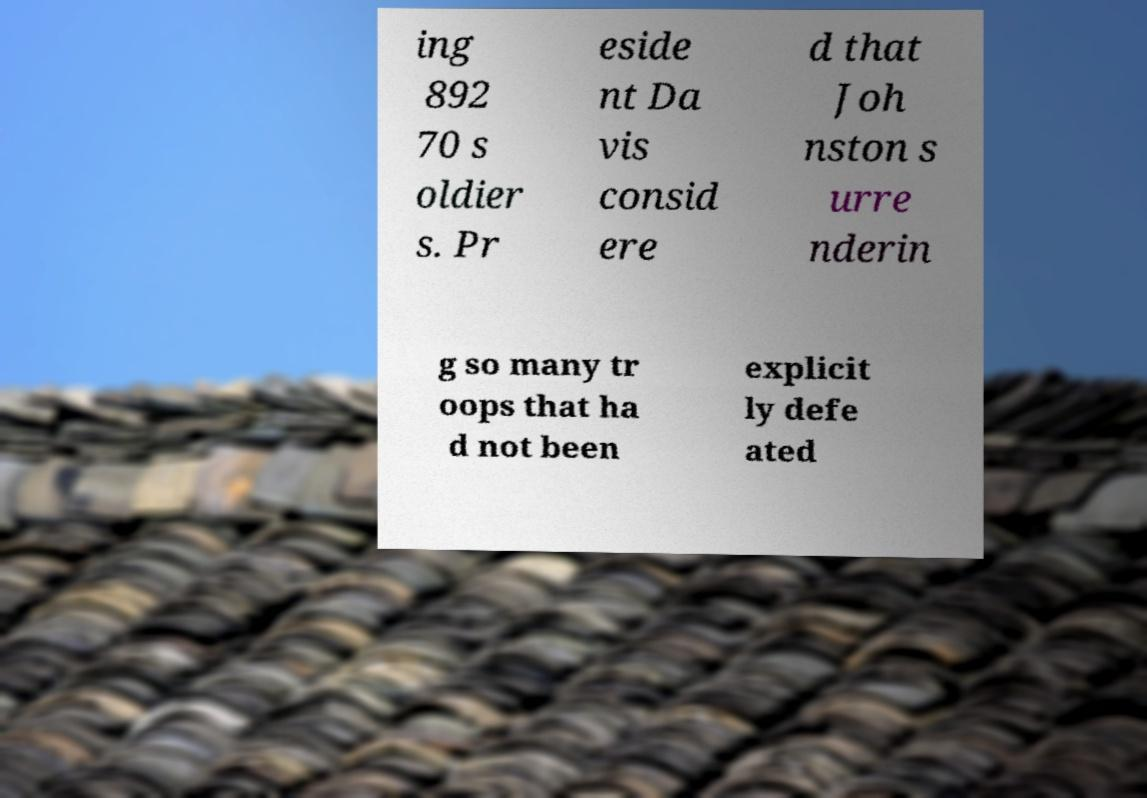There's text embedded in this image that I need extracted. Can you transcribe it verbatim? ing 892 70 s oldier s. Pr eside nt Da vis consid ere d that Joh nston s urre nderin g so many tr oops that ha d not been explicit ly defe ated 